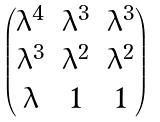<formula> <loc_0><loc_0><loc_500><loc_500>\begin{pmatrix} \lambda ^ { 4 } & \lambda ^ { 3 } & \lambda ^ { 3 } \\ \lambda ^ { 3 } & \lambda ^ { 2 } & \lambda ^ { 2 } \\ \lambda & 1 & 1 \end{pmatrix}</formula> 